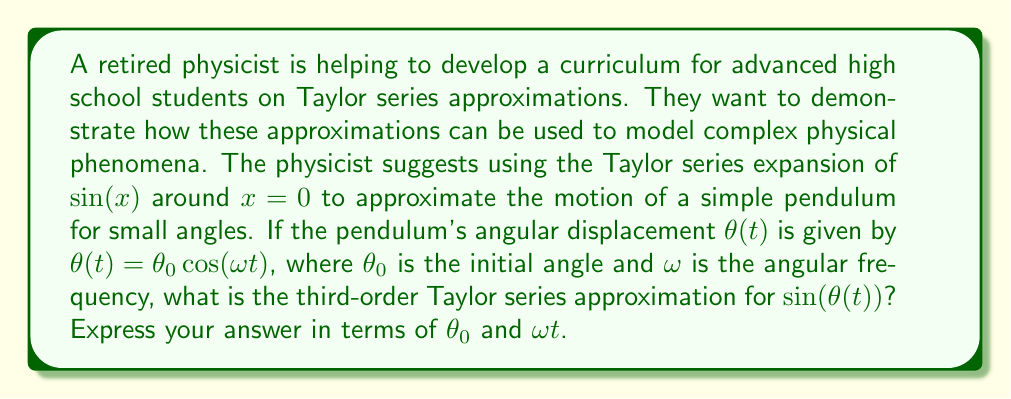Could you help me with this problem? Let's approach this step-by-step:

1) First, recall the Taylor series expansion for $\sin(x)$ around $x=0$:

   $$\sin(x) = x - \frac{x^3}{3!} + \frac{x^5}{5!} - \frac{x^7}{7!} + \cdots$$

2) We want the third-order approximation, so we'll use terms up to $x^3$:

   $$\sin(x) \approx x - \frac{x^3}{6}$$

3) In our case, $x = \theta(t) = \theta_0 \cos(\omega t)$. Let's substitute this:

   $$\sin(\theta(t)) \approx \theta_0 \cos(\omega t) - \frac{[\theta_0 \cos(\omega t)]^3}{6}$$

4) Expand the cube term:

   $$\sin(\theta(t)) \approx \theta_0 \cos(\omega t) - \frac{\theta_0^3 \cos^3(\omega t)}{6}$$

5) Now, we can use the trigonometric identity for $\cos^3(x)$:

   $$\cos^3(x) = \frac{3}{4}\cos(x) + \frac{1}{4}\cos(3x)$$

6) Substituting this into our approximation:

   $$\sin(\theta(t)) \approx \theta_0 \cos(\omega t) - \frac{\theta_0^3}{6} \left(\frac{3}{4}\cos(\omega t) + \frac{1}{4}\cos(3\omega t)\right)$$

7) Simplify:

   $$\sin(\theta(t)) \approx \theta_0 \cos(\omega t) - \frac{\theta_0^3}{8}\cos(\omega t) - \frac{\theta_0^3}{24}\cos(3\omega t)$$

8) Combine like terms:

   $$\sin(\theta(t)) \approx \left(\theta_0 - \frac{\theta_0^3}{8}\right)\cos(\omega t) - \frac{\theta_0^3}{24}\cos(3\omega t)$$

This is the third-order Taylor series approximation for $\sin(\theta(t))$.
Answer: $\left(\theta_0 - \frac{\theta_0^3}{8}\right)\cos(\omega t) - \frac{\theta_0^3}{24}\cos(3\omega t)$ 